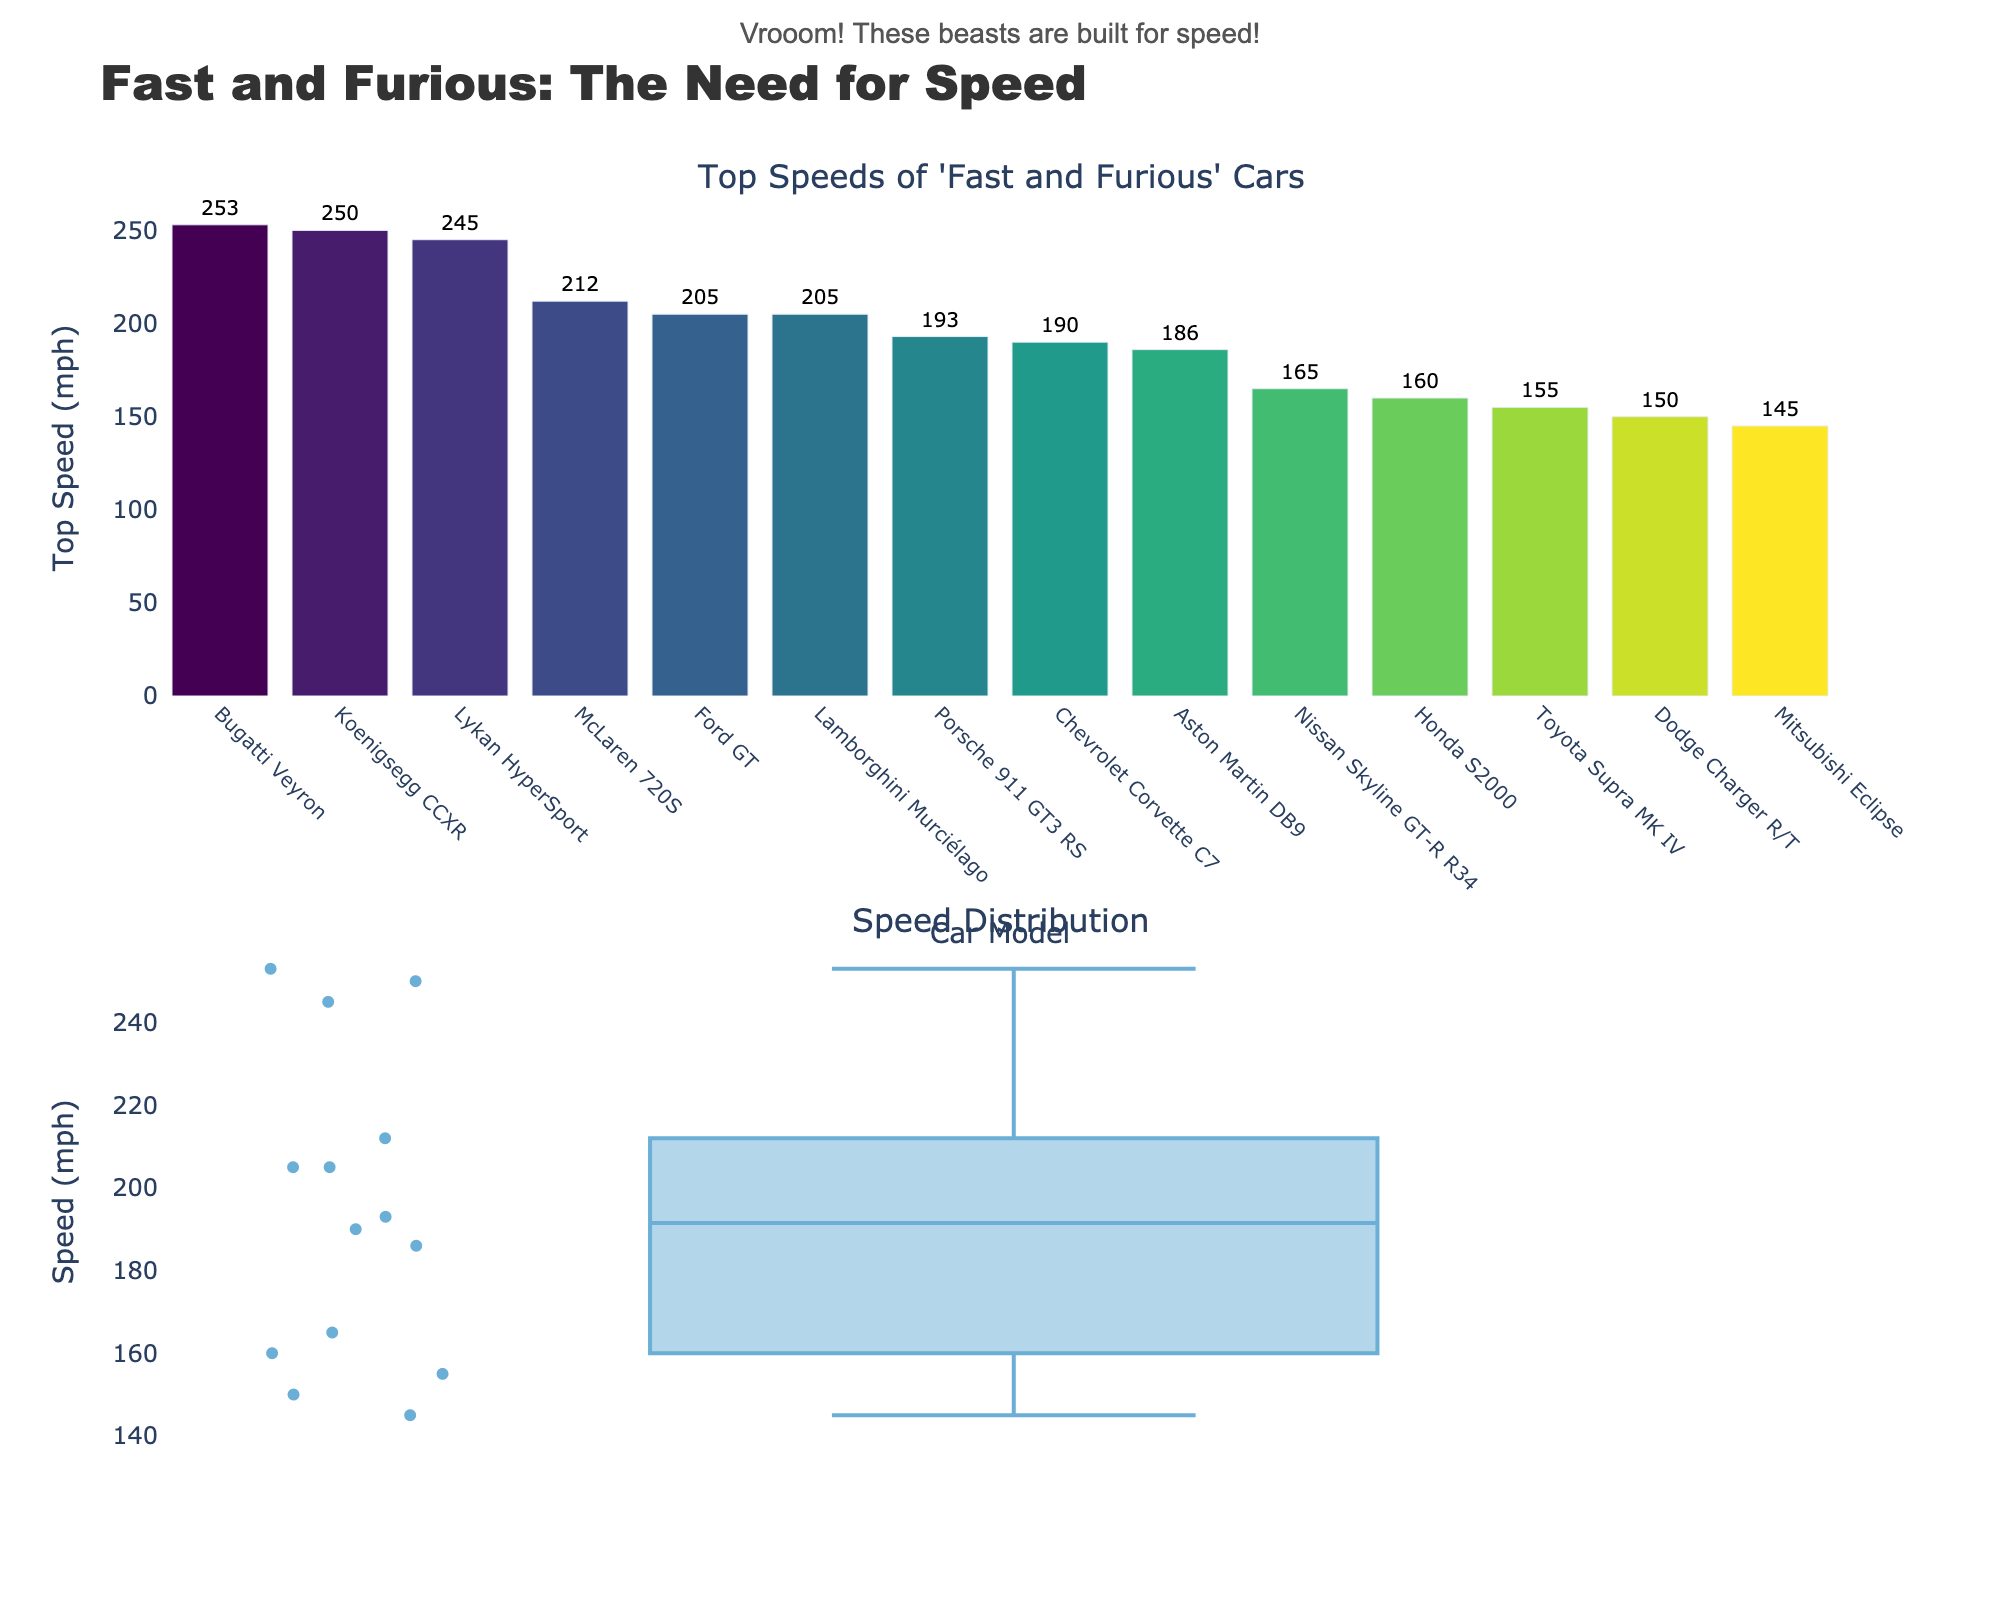What is the top speed of the Nissan Skyline GT-R R34? The figure has a bar for each car model showing its top speed. By looking at the bar labeled "Nissan Skyline GT-R R34," we can see its top speed.
Answer: 165 mph Which car has the highest top speed? The highest bar in the bar plot represents the car with the highest top speed. The tallest bar corresponds to the Bugatti Veyron.
Answer: Bugatti Veyron What is the difference between the top speeds of the Lykan HyperSport and the Lamborghini Murciélago? From the bar plot, the top speed of the Lykan HyperSport is 245 mph and for the Lamborghini Murciélago, it is 205 mph. The difference is calculated by subtracting 205 from 245.
Answer: 40 mph How many different car models are compared in the figure? Counting the number of bars in the bar plot indicates the number of different car models compared.
Answer: 14 What is the median top speed of the cars? The box plot shows the distribution of top speeds. The median value is indicated by the line inside the box. By examining the box plot, we can find this value.
Answer: Around 186 mph Between the Ford GT and the Chevrolet Corvette C7, which car has a higher top speed? By comparing the heights of the bars for the Ford GT (205 mph) and the Chevrolet Corvette C7 (190 mph), we see that the Ford GT has a higher top speed.
Answer: Ford GT Which car has a lower top speed, the Honda S2000 or the Mitsubishi Eclipse? By looking at the bars for the Honda S2000 and Mitsubishi Eclipse, the Honda S2000 has a top speed of 160 mph, and the Mitsubishi Eclipse has 145 mph. Hence, the Mitsubishi Eclipse has a lower top speed.
Answer: Mitsubishi Eclipse What is the average top speed of all the cars? To find the average top speed, sum the top speeds of all the cars and divide by the number of cars (14). The sum is (165 + 155 + 150 + 145 + 160 + 205 + 190 + 245 + 253 + 212 + 205 + 193 + 250 + 186) = 2914. The average is 2914 / 14.
Answer: 208 mph Is the top speed of the Koenigsegg CCXR closer to the Bugatti Veyron or the Lykan HyperSport? The top speeds are Koenigsegg CCXR (250 mph), Bugatti Veyron (253 mph), and Lykan HyperSport (245 mph). The difference between Koenigsegg CCXR and Bugatti Veyron is 3 mph, and the difference between Koenigsegg CCXR and Lykan HyperSport is 5 mph. The top speed of the Koenigsegg CCXR is closer to the Bugatti Veyron.
Answer: Bugatti Veyron What is the span (range) of the top speeds of all cars? The range of top speeds is calculated by subtracting the lowest top speed from the highest. The highest is 253 mph (Bugatti Veyron) and the lowest is 145 mph (Mitsubishi Eclipse). Hence, the range is 253 - 145.
Answer: 108 mph 